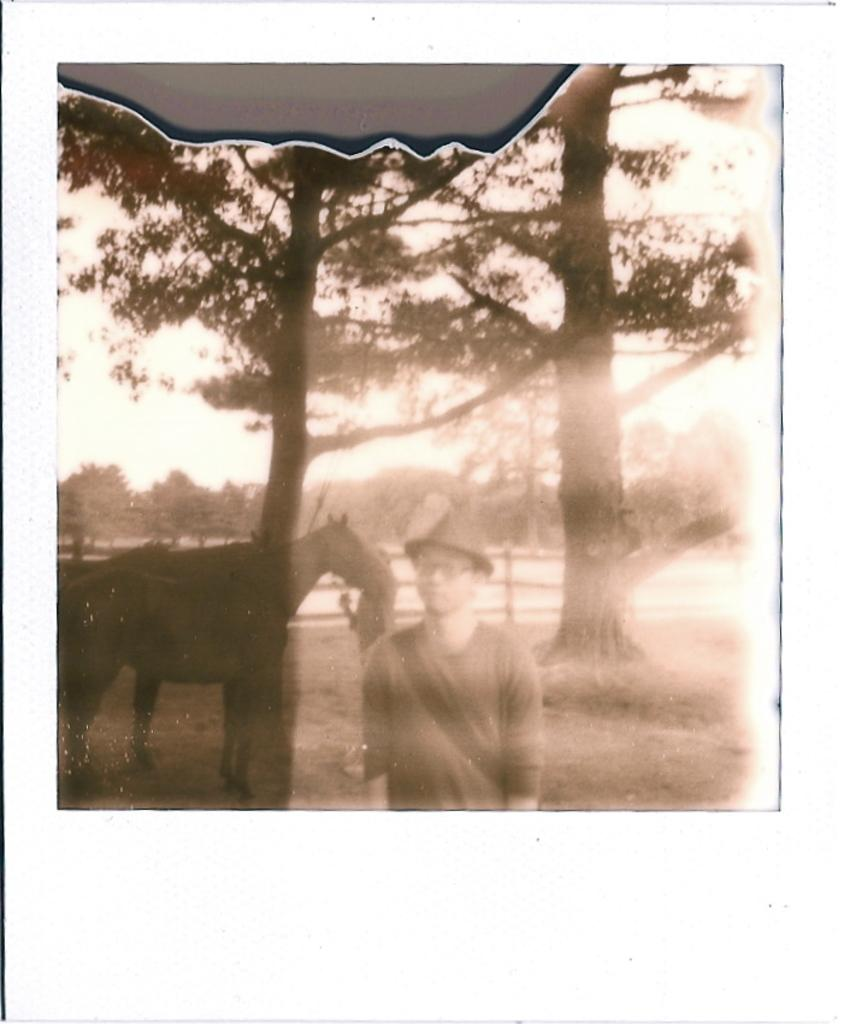Who or what can be seen in the image? There is a man and a horse in the image. What is visible in the background of the image? There are trees in the background of the image. What type of jelly is being used to ride the horse in the image? There is no jelly present in the image, and the horse is not being ridden. 